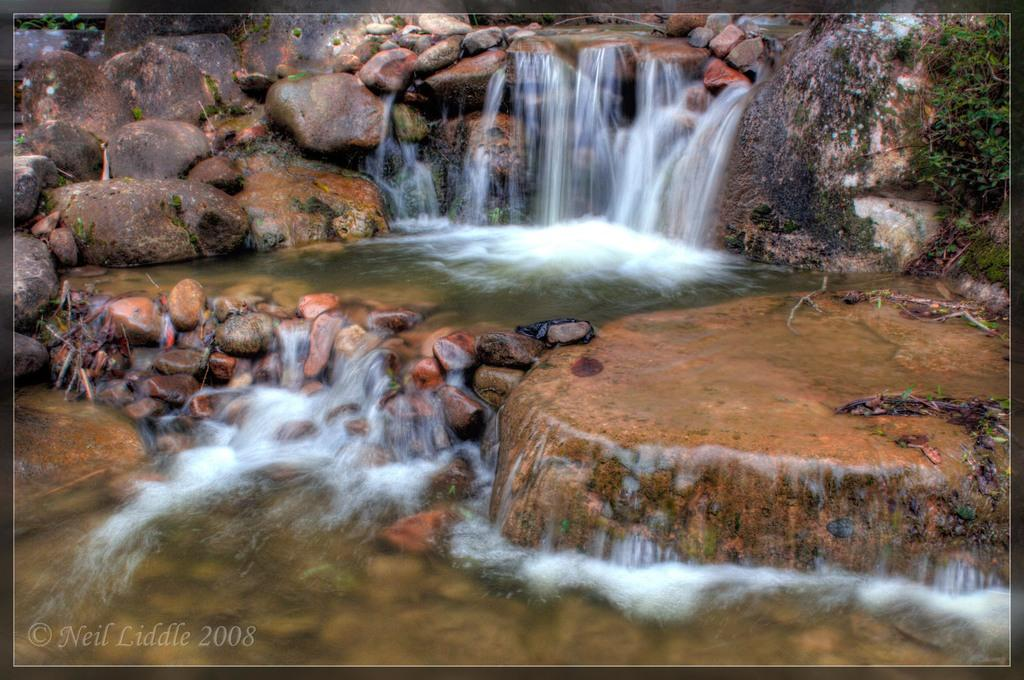What natural feature is the main subject of the image? There is a waterfall in the image. What type of objects can be seen near the waterfall? There are stones in the image. Where are plants located in the image? There are plants on both the left and right sides of the image. What type of trade is being conducted near the waterfall in the image? There is no indication of any trade or commercial activity in the image; it primarily features a waterfall and surrounding natural elements. 